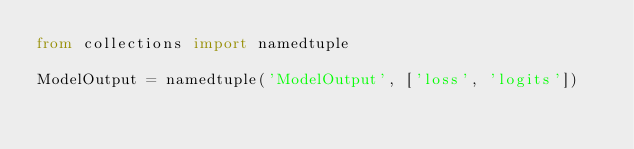Convert code to text. <code><loc_0><loc_0><loc_500><loc_500><_Python_>from collections import namedtuple

ModelOutput = namedtuple('ModelOutput', ['loss', 'logits'])
</code> 